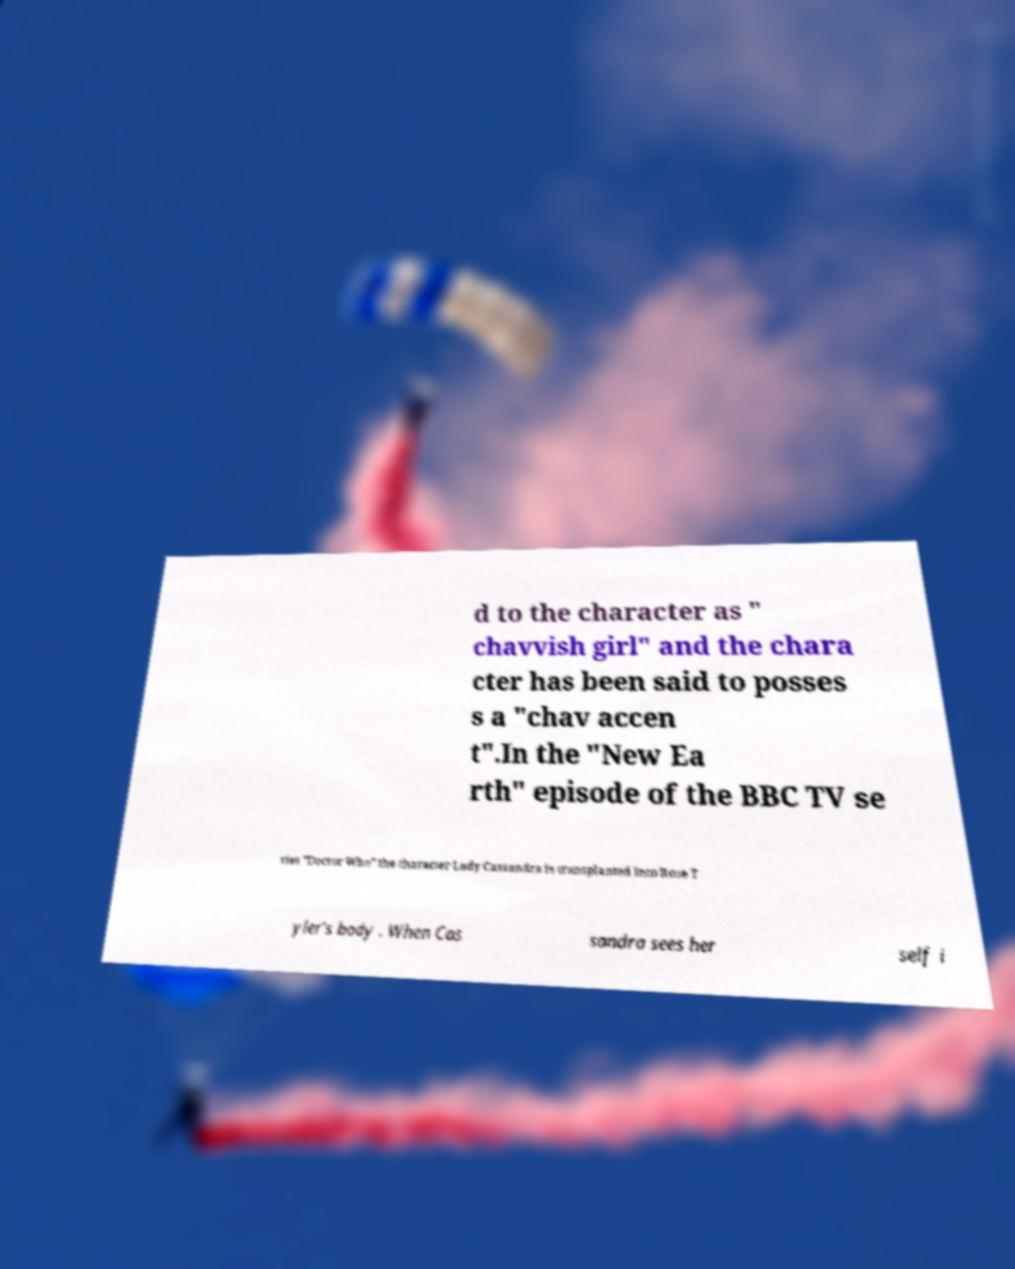Could you assist in decoding the text presented in this image and type it out clearly? d to the character as " chavvish girl" and the chara cter has been said to posses s a "chav accen t".In the "New Ea rth" episode of the BBC TV se ries "Doctor Who" the character Lady Cassandra is transplanted into Rose T yler's body . When Cas sandra sees her self i 